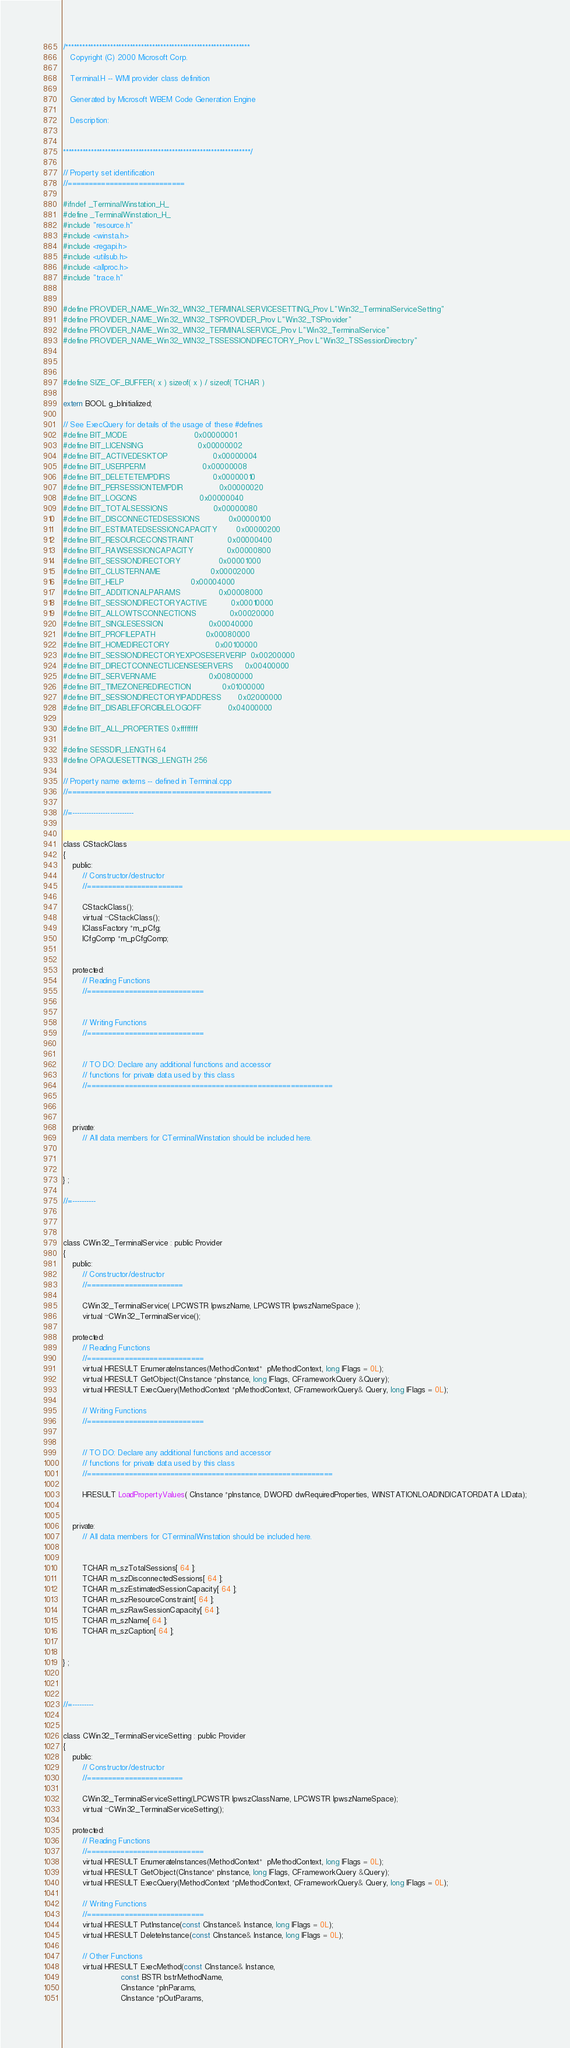<code> <loc_0><loc_0><loc_500><loc_500><_C_>/******************************************************************
   Copyright (C) 2000 Microsoft Corp.

   Terminal.H -- WMI provider class definition

   Generated by Microsoft WBEM Code Generation Engine
 
   Description: 
   

*******************************************************************/

// Property set identification
//============================

#ifndef _TerminalWinstation_H_
#define _TerminalWinstation_H_
#include "resource.h"
#include <winsta.h>
#include <regapi.h>
#include <utilsub.h>
#include <allproc.h>
#include "trace.h"


#define PROVIDER_NAME_Win32_WIN32_TERMINALSERVICESETTING_Prov L"Win32_TerminalServiceSetting"
#define PROVIDER_NAME_Win32_WIN32_TSPROVIDER_Prov L"Win32_TSProvider"
#define PROVIDER_NAME_Win32_WIN32_TERMINALSERVICE_Prov L"Win32_TerminalService"
#define PROVIDER_NAME_Win32_WIN32_TSSESSIONDIRECTORY_Prov L"Win32_TSSessionDirectory"



#define SIZE_OF_BUFFER( x ) sizeof( x ) / sizeof( TCHAR )

extern BOOL g_bInitialized;

// See ExecQuery for details of the usage of these #defines
#define BIT_MODE                            0x00000001
#define BIT_LICENSING                       0x00000002
#define BIT_ACTIVEDESKTOP                   0x00000004
#define BIT_USERPERM                        0x00000008
#define BIT_DELETETEMPDIRS                  0x00000010
#define BIT_PERSESSIONTEMPDIR               0x00000020
#define BIT_LOGONS                          0x00000040
#define BIT_TOTALSESSIONS                   0x00000080
#define BIT_DISCONNECTEDSESSIONS            0x00000100
#define BIT_ESTIMATEDSESSIONCAPACITY        0x00000200
#define BIT_RESOURCECONSTRAINT              0x00000400
#define BIT_RAWSESSIONCAPACITY              0x00000800
#define BIT_SESSIONDIRECTORY                0x00001000
#define BIT_CLUSTERNAME                     0x00002000
#define BIT_HELP                            0x00004000
#define BIT_ADDITIONALPARAMS                0x00008000
#define BIT_SESSIONDIRECTORYACTIVE          0x00010000
#define BIT_ALLOWTSCONNECTIONS              0x00020000
#define BIT_SINGLESESSION                   0x00040000
#define BIT_PROFILEPATH                     0x00080000
#define BIT_HOMEDIRECTORY                   0x00100000
#define BIT_SESSIONDIRECTORYEXPOSESERVERIP  0x00200000
#define BIT_DIRECTCONNECTLICENSESERVERS     0x00400000
#define BIT_SERVERNAME                      0x00800000
#define BIT_TIMEZONEREDIRECTION             0x01000000
#define BIT_SESSIONDIRECTORYIPADDRESS       0x02000000
#define BIT_DISABLEFORCIBLELOGOFF           0x04000000

#define BIT_ALL_PROPERTIES 0xffffffff

#define SESSDIR_LENGTH 64
#define OPAQUESETTINGS_LENGTH 256 

// Property name externs -- defined in Terminal.cpp
//=================================================

//=--------------------------


class CStackClass
{
    public:
        // Constructor/destructor
        //=======================

        CStackClass();
        virtual ~CStackClass();
        IClassFactory *m_pCfg;
        ICfgComp *m_pCfgComp;
		

    protected:
        // Reading Functions
        //============================
        

        // Writing Functions    
        //============================
       

        // TO DO: Declare any additional functions and accessor
        // functions for private data used by this class
        //===========================================================

    

    private:
        // All data members for CTerminalWinstation should be included here.  
		
   
        
} ;

//=----------



class CWin32_TerminalService : public Provider
{
    public:
        // Constructor/destructor
        //=======================

        CWin32_TerminalService( LPCWSTR lpwszName, LPCWSTR lpwszNameSpace );
        virtual ~CWin32_TerminalService();

    protected:
        // Reading Functions
        //============================
        virtual HRESULT EnumerateInstances(MethodContext*  pMethodContext, long lFlags = 0L);
        virtual HRESULT GetObject(CInstance *pInstance, long lFlags, CFrameworkQuery &Query);
        virtual HRESULT ExecQuery(MethodContext *pMethodContext, CFrameworkQuery& Query, long lFlags = 0L);

        // Writing Functions    
        //============================
       

        // TO DO: Declare any additional functions and accessor
        // functions for private data used by this class
        //===========================================================

        HRESULT LoadPropertyValues( CInstance *pInstance, DWORD dwRequiredProperties, WINSTATIONLOADINDICATORDATA LIData);
    

    private:
        // All data members for CTerminalWinstation should be included here.  
        
      
        TCHAR m_szTotalSessions[ 64 ];
        TCHAR m_szDisconnectedSessions[ 64 ];
        TCHAR m_szEstimatedSessionCapacity[ 64 ];
        TCHAR m_szResourceConstraint[ 64 ];
        TCHAR m_szRawSessionCapacity[ 64 ];
        TCHAR m_szName[ 64 ];
        TCHAR m_szCaption[ 64 ];
       
        
} ;



//=---------


class CWin32_TerminalServiceSetting : public Provider
{
    public:
        // Constructor/destructor
        //=======================

        CWin32_TerminalServiceSetting(LPCWSTR lpwszClassName, LPCWSTR lpwszNameSpace);
        virtual ~CWin32_TerminalServiceSetting();

    protected:
        // Reading Functions
        //============================
        virtual HRESULT EnumerateInstances(MethodContext*  pMethodContext, long lFlags = 0L);
        virtual HRESULT GetObject(CInstance* pInstance, long lFlags, CFrameworkQuery &Query);
        virtual HRESULT ExecQuery(MethodContext *pMethodContext, CFrameworkQuery& Query, long lFlags = 0L);

        // Writing Functions    
        //============================
        virtual HRESULT PutInstance(const CInstance& Instance, long lFlags = 0L);
        virtual HRESULT DeleteInstance(const CInstance& Instance, long lFlags = 0L);

        // Other Functions
        virtual HRESULT ExecMethod(const CInstance& Instance,
                        const BSTR bstrMethodName,
                        CInstance *pInParams,
                        CInstance *pOutParams,</code> 